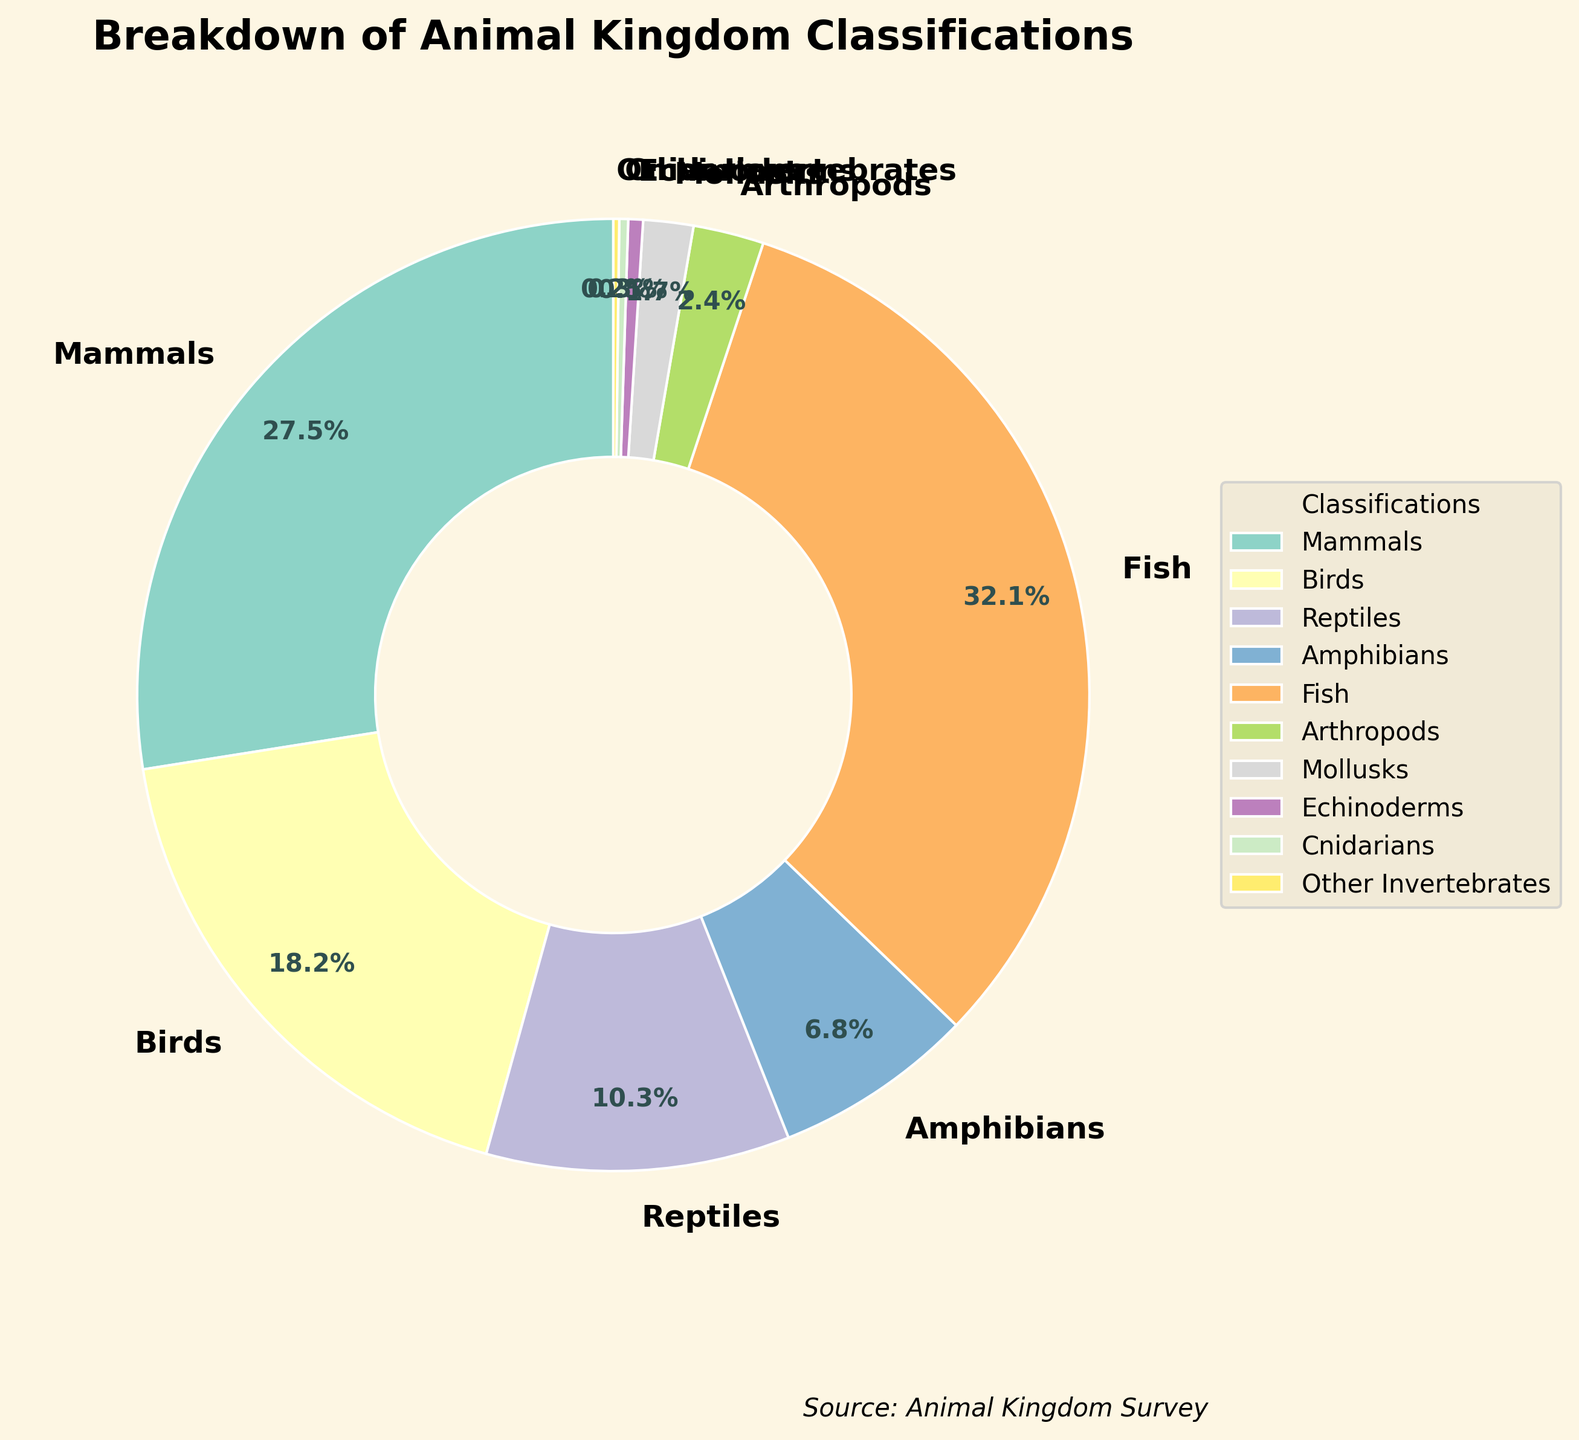Which classification has the highest percentage? By looking at the data represented in the pie chart, it is clear that Fish has the largest slice, which means it has the highest percentage.
Answer: Fish What is the combined percentage of Amphibians and Reptiles? From the chart, Amphibians have 6.8% and Reptiles have 10.3%. Adding these together: 6.8 + 10.3 = 17.1.
Answer: 17.1% How much greater is the percentage of Mammals compared to Mollusks? Mammals have 27.5% and Mollusks have 1.7%. The difference is 27.5 - 1.7 = 25.8.
Answer: 25.8% Identify two classifications with a combined percentage of more than 50%. Looking at the percentages, Fish (32.1%) and Mammals (27.5%) together sum up to 32.1 + 27.5 = 59.6, which is more than 50%.
Answer: Fish and Mammals Out of Birds and Reptiles, which classification has a smaller percentage? The pie chart shows that Birds have 18.2% and Reptiles have 10.3%. Since 10.3% is the smaller value, Reptiles have a smaller percentage.
Answer: Reptiles What percentage is represented by all invertebrates combined? The invertebrate classifications include Arthropods (2.4%), Mollusks (1.7%), Echinoderms (0.5%), Cnidarians (0.3%), and Other Invertebrates (0.2%). Adding these gives: 2.4 + 1.7 + 0.5 + 0.3 + 0.2 = 5.1.
Answer: 5.1% Which classification's percentage is closest to one-third of the total pie? One-third of the total percentage is approximately 33.3%. From the chart, Fish has 32.1%, which is closest to 33.3%.
Answer: Fish What is the visual indication used to identify the different classifications in the pie chart? The pie chart uses different colors to visually distinguish each classification section.
Answer: Different colors Is there any classification with a percentage below 1%? If yes, name it. Yes, there are classifications with percentages below 1%. They are Echinoderms (0.5%), Cnidarians (0.3%), and Other Invertebrates (0.2%).
Answer: Echinoderms, Cnidarians, Other Invertebrates 